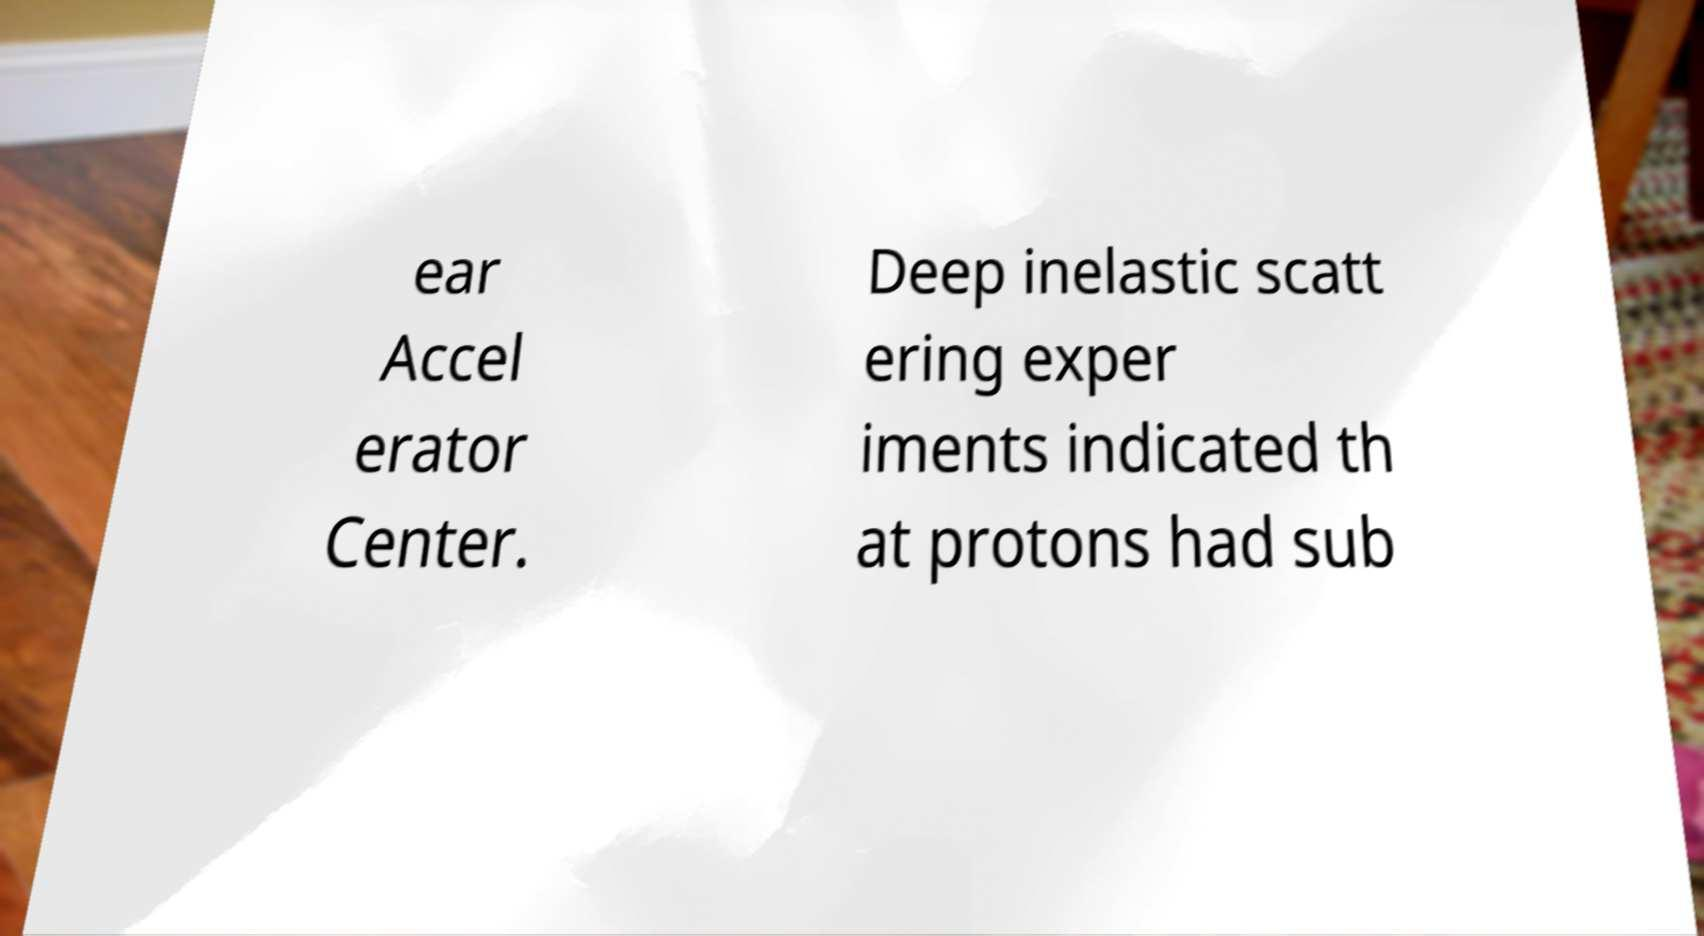Can you read and provide the text displayed in the image?This photo seems to have some interesting text. Can you extract and type it out for me? ear Accel erator Center. Deep inelastic scatt ering exper iments indicated th at protons had sub 